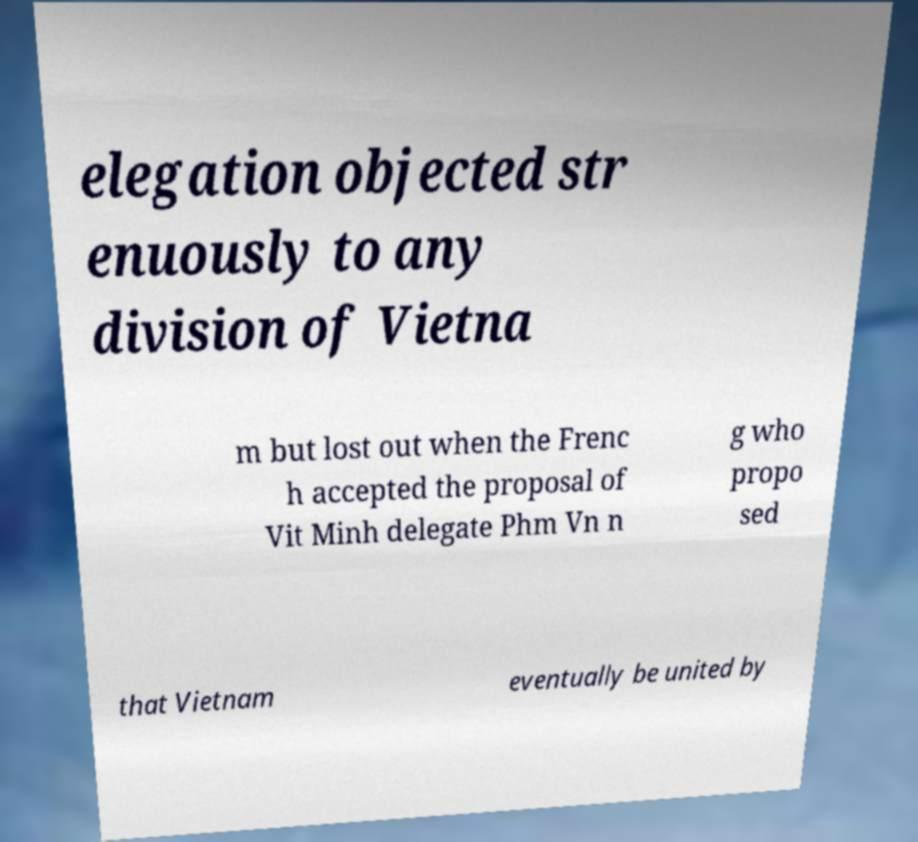Can you accurately transcribe the text from the provided image for me? elegation objected str enuously to any division of Vietna m but lost out when the Frenc h accepted the proposal of Vit Minh delegate Phm Vn n g who propo sed that Vietnam eventually be united by 